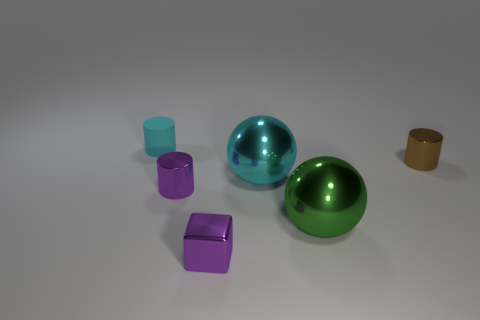Subtract all cyan cylinders. How many cylinders are left? 2 Add 2 tiny purple cylinders. How many objects exist? 8 Subtract all cyan balls. How many balls are left? 1 Subtract 1 balls. How many balls are left? 1 Add 1 large cyan metallic spheres. How many large cyan metallic spheres exist? 2 Subtract 1 cyan cylinders. How many objects are left? 5 Subtract all spheres. How many objects are left? 4 Subtract all red blocks. Subtract all yellow cylinders. How many blocks are left? 1 Subtract all yellow cylinders. How many green spheres are left? 1 Subtract all brown metallic cylinders. Subtract all tiny cyan rubber cylinders. How many objects are left? 4 